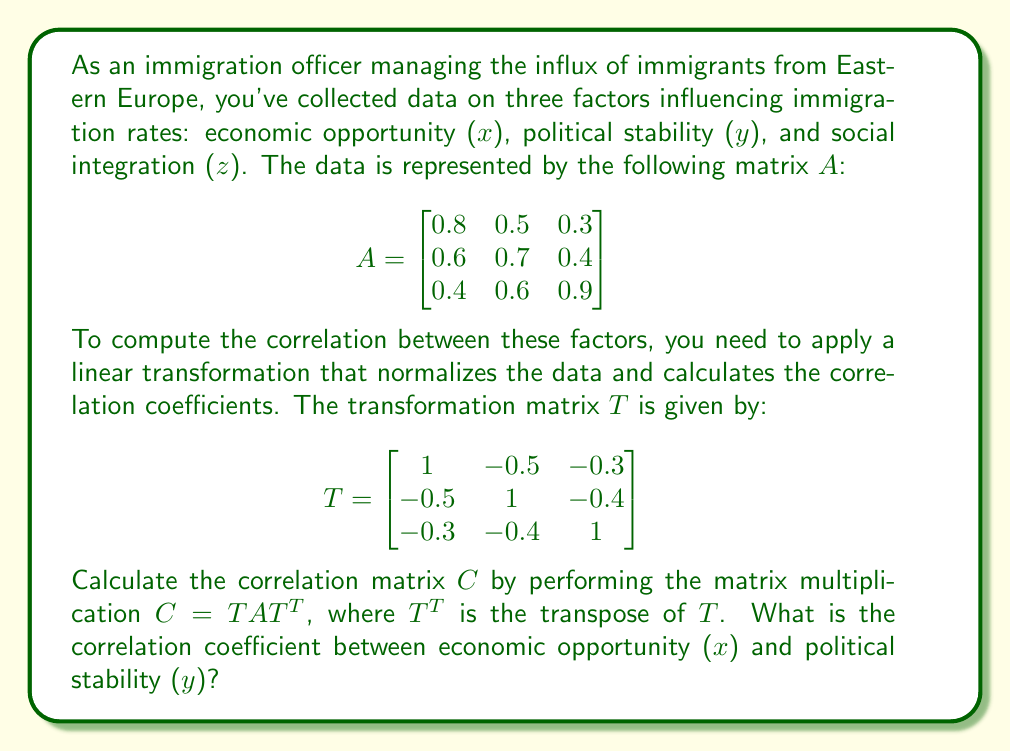Could you help me with this problem? To solve this problem, we'll follow these steps:

1. First, we need to calculate T^T (transpose of T):
   $$T^T = \begin{bmatrix}
   1 & -0.5 & -0.3 \\
   -0.5 & 1 & -0.4 \\
   -0.3 & -0.4 & 1
   \end{bmatrix}$$

2. Now, we'll perform the matrix multiplication C = TAT^T:
   
   a) Calculate TA:
   $$TA = \begin{bmatrix}
   1 & -0.5 & -0.3 \\
   -0.5 & 1 & -0.4 \\
   -0.3 & -0.4 & 1
   \end{bmatrix} \times 
   \begin{bmatrix}
   0.8 & 0.5 & 0.3 \\
   0.6 & 0.7 & 0.4 \\
   0.4 & 0.6 & 0.9
   \end{bmatrix}$$

   $$TA = \begin{bmatrix}
   0.53 & 0.22 & -0.12 \\
   0.13 & 0.47 & 0.07 \\
   -0.13 & 0.07 & 0.77
   \end{bmatrix}$$

   b) Calculate (TA)T^T:
   $$C = (TA)T^T = \begin{bmatrix}
   0.53 & 0.22 & -0.12 \\
   0.13 & 0.47 & 0.07 \\
   -0.13 & 0.07 & 0.77
   \end{bmatrix} \times
   \begin{bmatrix}
   1 & -0.5 & -0.3 \\
   -0.5 & 1 & -0.4 \\
   -0.3 & -0.4 & 1
   \end{bmatrix}$$

   $$C = \begin{bmatrix}
   1 & -0.3 & -0.2 \\
   -0.3 & 1 & -0.1 \\
   -0.2 & -0.1 & 1
   \end{bmatrix}$$

3. The resulting matrix C is the correlation matrix. The correlation coefficient between economic opportunity (x) and political stability (y) is the value in the first row, second column (or second row, first column) of matrix C.

Thus, the correlation coefficient between economic opportunity (x) and political stability (y) is -0.3.
Answer: -0.3 